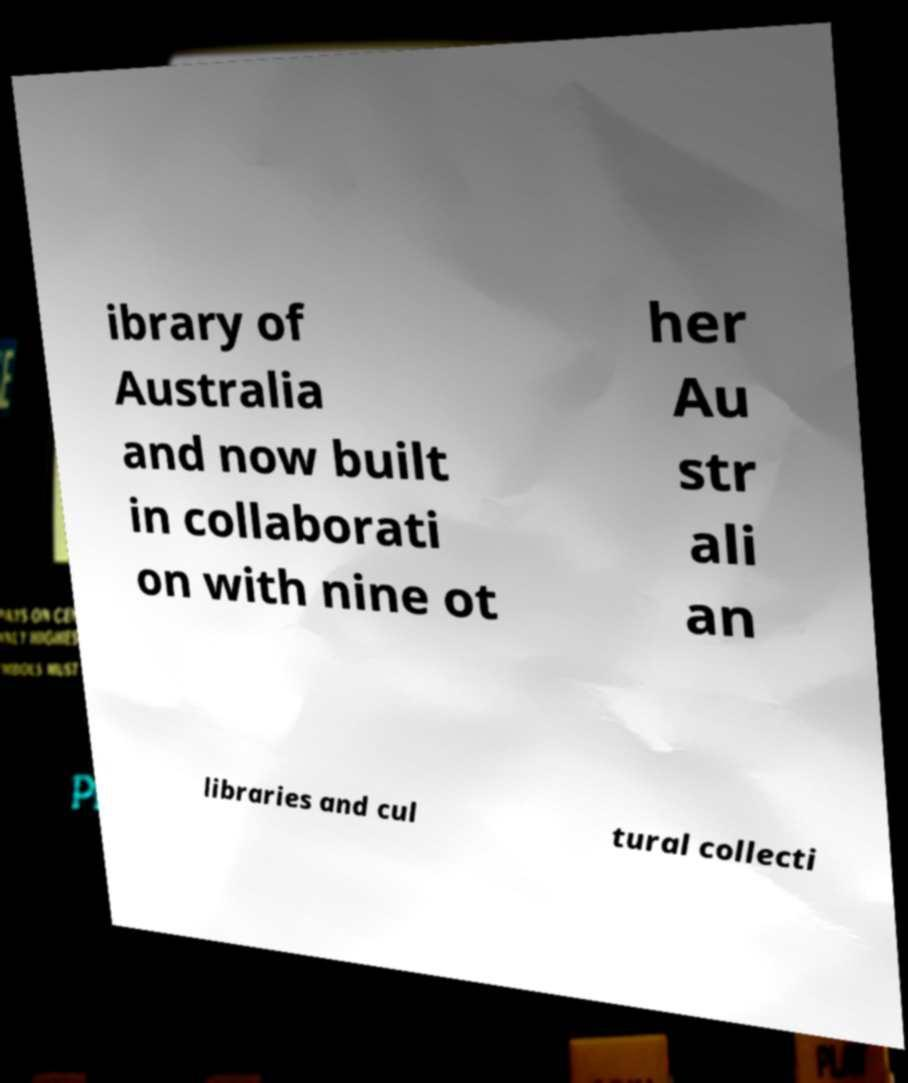Can you read and provide the text displayed in the image?This photo seems to have some interesting text. Can you extract and type it out for me? ibrary of Australia and now built in collaborati on with nine ot her Au str ali an libraries and cul tural collecti 